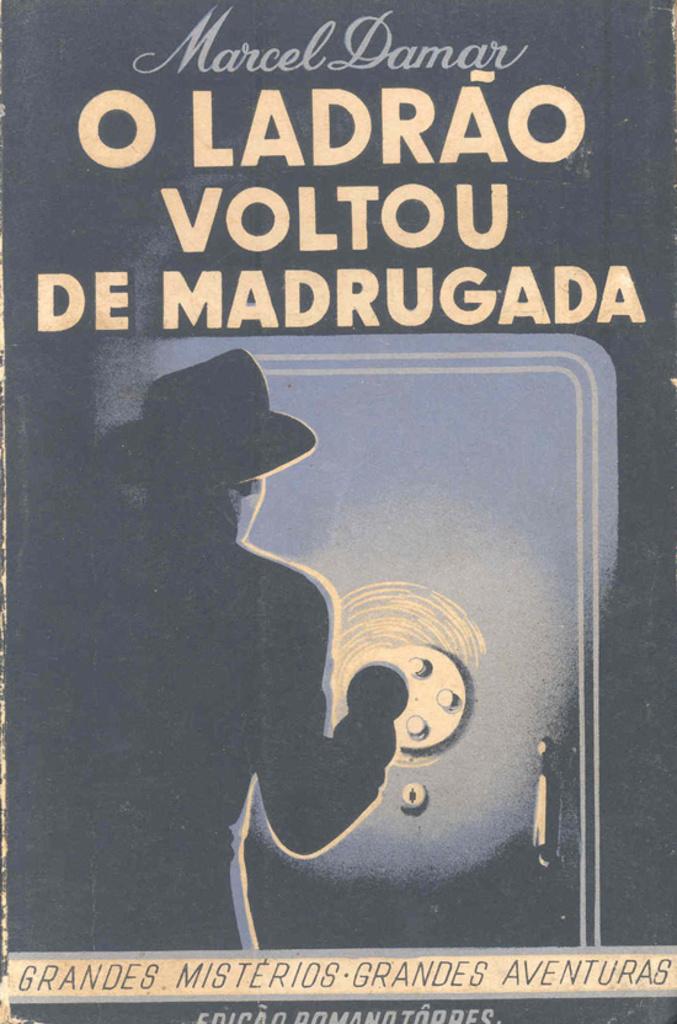Who is the author?
Provide a short and direct response. Marcel damar. What is the title of the book?
Offer a very short reply. O ladrao voltou de madrugada. 